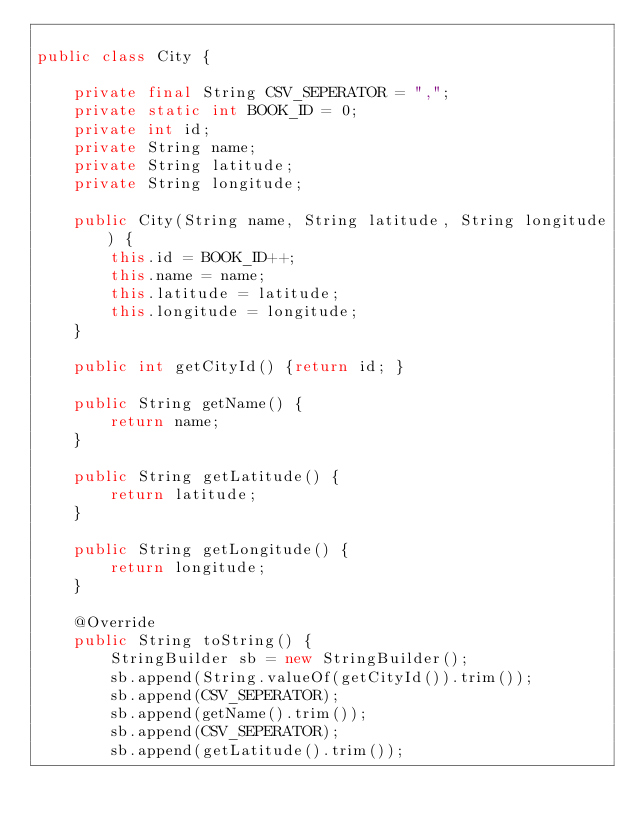<code> <loc_0><loc_0><loc_500><loc_500><_Java_>
public class City {

    private final String CSV_SEPERATOR = ",";
    private static int BOOK_ID = 0;
    private int id;
    private String name;
    private String latitude;
    private String longitude;

    public City(String name, String latitude, String longitude) {
        this.id = BOOK_ID++;
        this.name = name;
        this.latitude = latitude;
        this.longitude = longitude;
    }

    public int getCityId() {return id; }
    
    public String getName() {
        return name;
    }

    public String getLatitude() {
        return latitude;
    }

    public String getLongitude() {
        return longitude;
    }

    @Override
    public String toString() {
        StringBuilder sb = new StringBuilder();
        sb.append(String.valueOf(getCityId()).trim());
        sb.append(CSV_SEPERATOR);
        sb.append(getName().trim());
        sb.append(CSV_SEPERATOR);
        sb.append(getLatitude().trim());</code> 